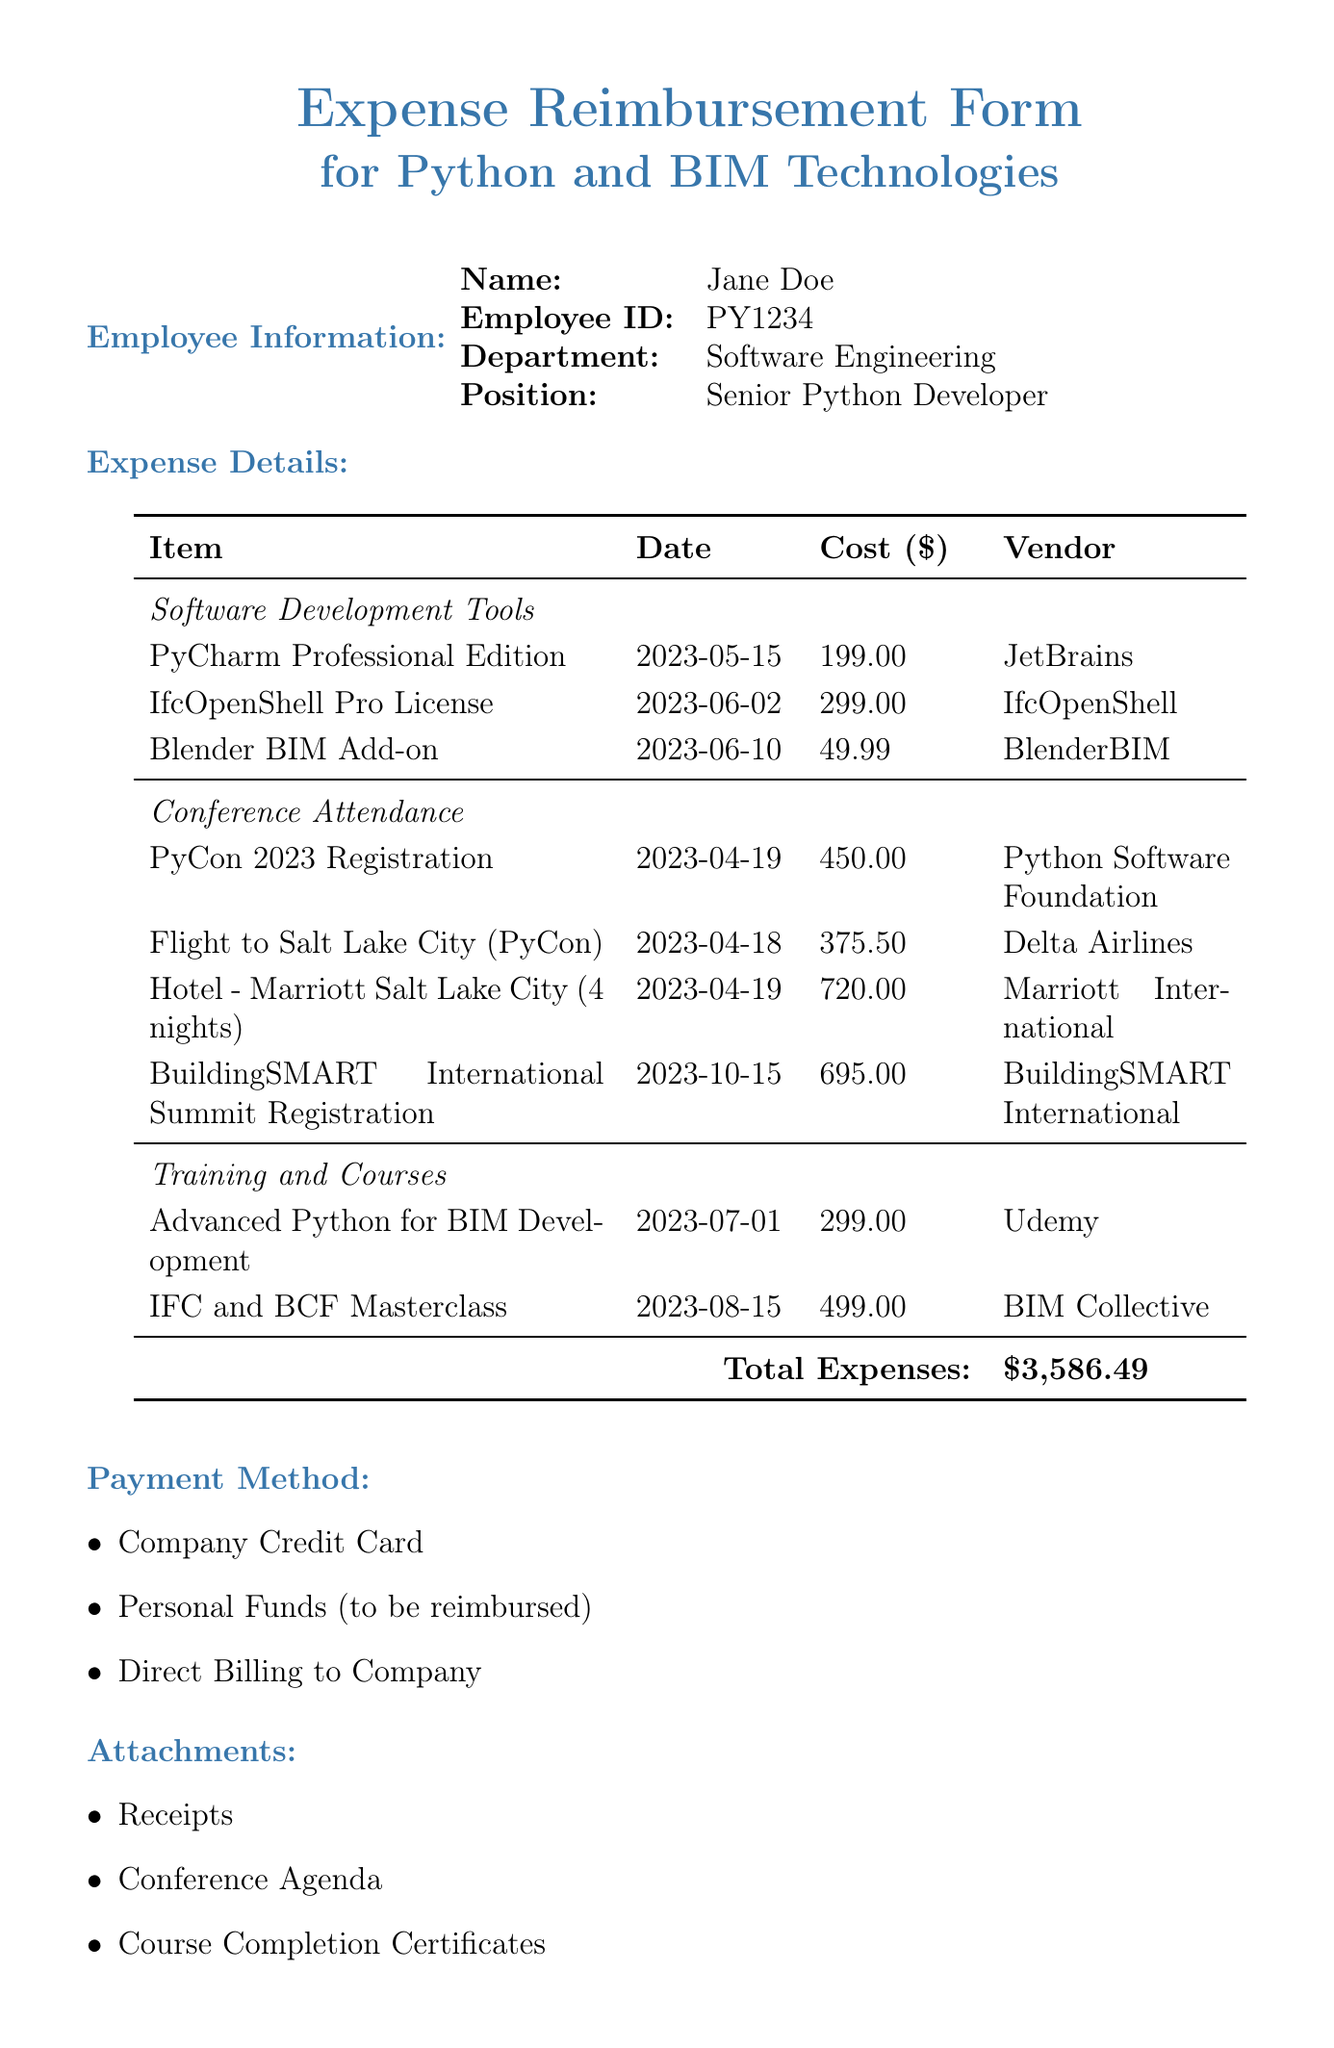What is the total amount of expenses? The total expenses are listed at the bottom of the expense details section, summing up all categories of expenses.
Answer: $3,586.49 Who is the employee submitting the form? The employee's name is provided in the employee information section of the document.
Answer: Jane Doe What is the cost of the IfcOpenShell Pro License? The cost of each item is detailed in the expense details section, specifically under Software Development Tools.
Answer: $299.00 What date was the PyCon 2023 Registration made? The date of this expense is found next to the item in the Conference Attendance section.
Answer: 2023-04-19 What attachments are included with this expense reimbursement form? The attachments section lists the documents that accompany the reimbursement form.
Answer: Receipts, Conference Agenda, Course Completion Certificates Who is the manager that will approve the expenses? The manager’s information is listed in the approval information section of the document.
Answer: John Smith Which payment method is associated with this reimbursement? The different payment methods are outlined in a specific section of the document.
Answer: Company Credit Card What is the position of the employee submitting the form? The position is explicitly mentioned in the employee information section.
Answer: Senior Python Developer What was the cost of the hotel stay during the conference? The hotel cost is provided in the Conference Attendance category of the expense details.
Answer: $720.00 